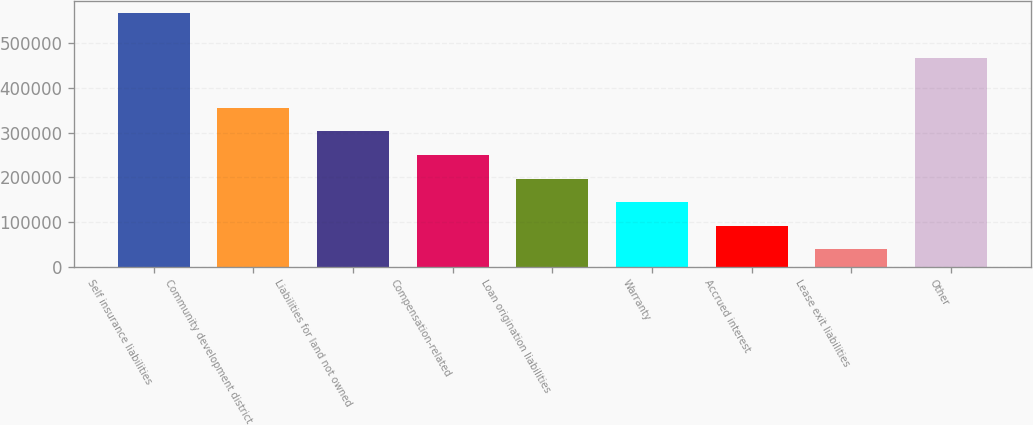<chart> <loc_0><loc_0><loc_500><loc_500><bar_chart><fcel>Self insurance liabilities<fcel>Community development district<fcel>Liabilities for land not owned<fcel>Compensation-related<fcel>Loan origination liabilities<fcel>Warranty<fcel>Accrued interest<fcel>Lease exit liabilities<fcel>Other<nl><fcel>566693<fcel>355452<fcel>302642<fcel>249832<fcel>197022<fcel>144211<fcel>91401.2<fcel>38591<fcel>466963<nl></chart> 